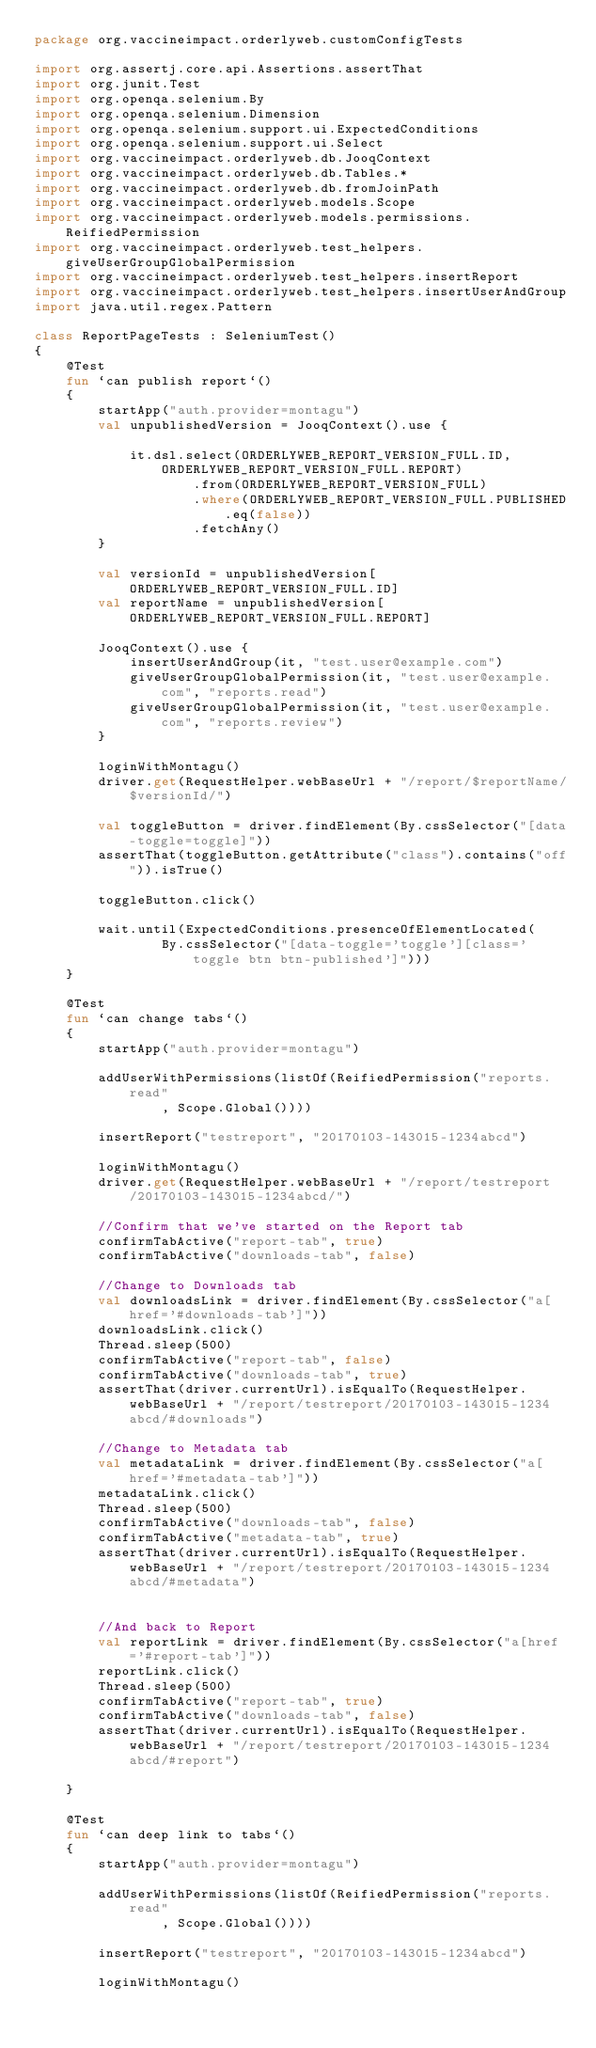<code> <loc_0><loc_0><loc_500><loc_500><_Kotlin_>package org.vaccineimpact.orderlyweb.customConfigTests

import org.assertj.core.api.Assertions.assertThat
import org.junit.Test
import org.openqa.selenium.By
import org.openqa.selenium.Dimension
import org.openqa.selenium.support.ui.ExpectedConditions
import org.openqa.selenium.support.ui.Select
import org.vaccineimpact.orderlyweb.db.JooqContext
import org.vaccineimpact.orderlyweb.db.Tables.*
import org.vaccineimpact.orderlyweb.db.fromJoinPath
import org.vaccineimpact.orderlyweb.models.Scope
import org.vaccineimpact.orderlyweb.models.permissions.ReifiedPermission
import org.vaccineimpact.orderlyweb.test_helpers.giveUserGroupGlobalPermission
import org.vaccineimpact.orderlyweb.test_helpers.insertReport
import org.vaccineimpact.orderlyweb.test_helpers.insertUserAndGroup
import java.util.regex.Pattern

class ReportPageTests : SeleniumTest()
{
    @Test
    fun `can publish report`()
    {
        startApp("auth.provider=montagu")
        val unpublishedVersion = JooqContext().use {

            it.dsl.select(ORDERLYWEB_REPORT_VERSION_FULL.ID, ORDERLYWEB_REPORT_VERSION_FULL.REPORT)
                    .from(ORDERLYWEB_REPORT_VERSION_FULL)
                    .where(ORDERLYWEB_REPORT_VERSION_FULL.PUBLISHED.eq(false))
                    .fetchAny()
        }

        val versionId = unpublishedVersion[ORDERLYWEB_REPORT_VERSION_FULL.ID]
        val reportName = unpublishedVersion[ORDERLYWEB_REPORT_VERSION_FULL.REPORT]

        JooqContext().use {
            insertUserAndGroup(it, "test.user@example.com")
            giveUserGroupGlobalPermission(it, "test.user@example.com", "reports.read")
            giveUserGroupGlobalPermission(it, "test.user@example.com", "reports.review")
        }

        loginWithMontagu()
        driver.get(RequestHelper.webBaseUrl + "/report/$reportName/$versionId/")

        val toggleButton = driver.findElement(By.cssSelector("[data-toggle=toggle]"))
        assertThat(toggleButton.getAttribute("class").contains("off")).isTrue()

        toggleButton.click()

        wait.until(ExpectedConditions.presenceOfElementLocated(
                By.cssSelector("[data-toggle='toggle'][class='toggle btn btn-published']")))
    }

    @Test
    fun `can change tabs`()
    {
        startApp("auth.provider=montagu")

        addUserWithPermissions(listOf(ReifiedPermission("reports.read"
                , Scope.Global())))

        insertReport("testreport", "20170103-143015-1234abcd")

        loginWithMontagu()
        driver.get(RequestHelper.webBaseUrl + "/report/testreport/20170103-143015-1234abcd/")

        //Confirm that we've started on the Report tab
        confirmTabActive("report-tab", true)
        confirmTabActive("downloads-tab", false)

        //Change to Downloads tab
        val downloadsLink = driver.findElement(By.cssSelector("a[href='#downloads-tab']"))
        downloadsLink.click()
        Thread.sleep(500)
        confirmTabActive("report-tab", false)
        confirmTabActive("downloads-tab", true)
        assertThat(driver.currentUrl).isEqualTo(RequestHelper.webBaseUrl + "/report/testreport/20170103-143015-1234abcd/#downloads")

        //Change to Metadata tab
        val metadataLink = driver.findElement(By.cssSelector("a[href='#metadata-tab']"))
        metadataLink.click()
        Thread.sleep(500)
        confirmTabActive("downloads-tab", false)
        confirmTabActive("metadata-tab", true)
        assertThat(driver.currentUrl).isEqualTo(RequestHelper.webBaseUrl + "/report/testreport/20170103-143015-1234abcd/#metadata")


        //And back to Report
        val reportLink = driver.findElement(By.cssSelector("a[href='#report-tab']"))
        reportLink.click()
        Thread.sleep(500)
        confirmTabActive("report-tab", true)
        confirmTabActive("downloads-tab", false)
        assertThat(driver.currentUrl).isEqualTo(RequestHelper.webBaseUrl + "/report/testreport/20170103-143015-1234abcd/#report")

    }

    @Test
    fun `can deep link to tabs`()
    {
        startApp("auth.provider=montagu")

        addUserWithPermissions(listOf(ReifiedPermission("reports.read"
                , Scope.Global())))

        insertReport("testreport", "20170103-143015-1234abcd")

        loginWithMontagu()</code> 